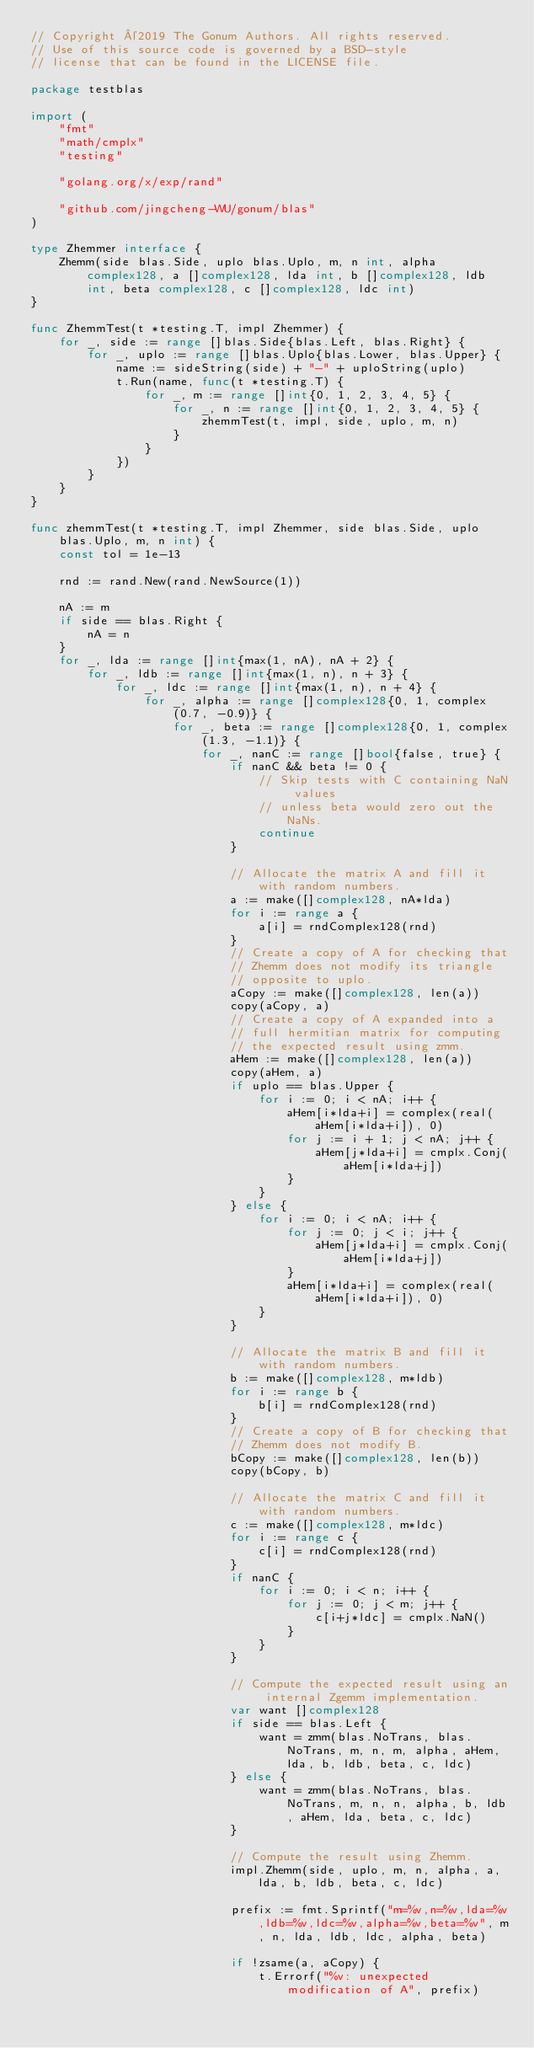<code> <loc_0><loc_0><loc_500><loc_500><_Go_>// Copyright ©2019 The Gonum Authors. All rights reserved.
// Use of this source code is governed by a BSD-style
// license that can be found in the LICENSE file.

package testblas

import (
	"fmt"
	"math/cmplx"
	"testing"

	"golang.org/x/exp/rand"

	"github.com/jingcheng-WU/gonum/blas"
)

type Zhemmer interface {
	Zhemm(side blas.Side, uplo blas.Uplo, m, n int, alpha complex128, a []complex128, lda int, b []complex128, ldb int, beta complex128, c []complex128, ldc int)
}

func ZhemmTest(t *testing.T, impl Zhemmer) {
	for _, side := range []blas.Side{blas.Left, blas.Right} {
		for _, uplo := range []blas.Uplo{blas.Lower, blas.Upper} {
			name := sideString(side) + "-" + uploString(uplo)
			t.Run(name, func(t *testing.T) {
				for _, m := range []int{0, 1, 2, 3, 4, 5} {
					for _, n := range []int{0, 1, 2, 3, 4, 5} {
						zhemmTest(t, impl, side, uplo, m, n)
					}
				}
			})
		}
	}
}

func zhemmTest(t *testing.T, impl Zhemmer, side blas.Side, uplo blas.Uplo, m, n int) {
	const tol = 1e-13

	rnd := rand.New(rand.NewSource(1))

	nA := m
	if side == blas.Right {
		nA = n
	}
	for _, lda := range []int{max(1, nA), nA + 2} {
		for _, ldb := range []int{max(1, n), n + 3} {
			for _, ldc := range []int{max(1, n), n + 4} {
				for _, alpha := range []complex128{0, 1, complex(0.7, -0.9)} {
					for _, beta := range []complex128{0, 1, complex(1.3, -1.1)} {
						for _, nanC := range []bool{false, true} {
							if nanC && beta != 0 {
								// Skip tests with C containing NaN values
								// unless beta would zero out the NaNs.
								continue
							}

							// Allocate the matrix A and fill it with random numbers.
							a := make([]complex128, nA*lda)
							for i := range a {
								a[i] = rndComplex128(rnd)
							}
							// Create a copy of A for checking that
							// Zhemm does not modify its triangle
							// opposite to uplo.
							aCopy := make([]complex128, len(a))
							copy(aCopy, a)
							// Create a copy of A expanded into a
							// full hermitian matrix for computing
							// the expected result using zmm.
							aHem := make([]complex128, len(a))
							copy(aHem, a)
							if uplo == blas.Upper {
								for i := 0; i < nA; i++ {
									aHem[i*lda+i] = complex(real(aHem[i*lda+i]), 0)
									for j := i + 1; j < nA; j++ {
										aHem[j*lda+i] = cmplx.Conj(aHem[i*lda+j])
									}
								}
							} else {
								for i := 0; i < nA; i++ {
									for j := 0; j < i; j++ {
										aHem[j*lda+i] = cmplx.Conj(aHem[i*lda+j])
									}
									aHem[i*lda+i] = complex(real(aHem[i*lda+i]), 0)
								}
							}

							// Allocate the matrix B and fill it with random numbers.
							b := make([]complex128, m*ldb)
							for i := range b {
								b[i] = rndComplex128(rnd)
							}
							// Create a copy of B for checking that
							// Zhemm does not modify B.
							bCopy := make([]complex128, len(b))
							copy(bCopy, b)

							// Allocate the matrix C and fill it with random numbers.
							c := make([]complex128, m*ldc)
							for i := range c {
								c[i] = rndComplex128(rnd)
							}
							if nanC {
								for i := 0; i < n; i++ {
									for j := 0; j < m; j++ {
										c[i+j*ldc] = cmplx.NaN()
									}
								}
							}

							// Compute the expected result using an internal Zgemm implementation.
							var want []complex128
							if side == blas.Left {
								want = zmm(blas.NoTrans, blas.NoTrans, m, n, m, alpha, aHem, lda, b, ldb, beta, c, ldc)
							} else {
								want = zmm(blas.NoTrans, blas.NoTrans, m, n, n, alpha, b, ldb, aHem, lda, beta, c, ldc)
							}

							// Compute the result using Zhemm.
							impl.Zhemm(side, uplo, m, n, alpha, a, lda, b, ldb, beta, c, ldc)

							prefix := fmt.Sprintf("m=%v,n=%v,lda=%v,ldb=%v,ldc=%v,alpha=%v,beta=%v", m, n, lda, ldb, ldc, alpha, beta)

							if !zsame(a, aCopy) {
								t.Errorf("%v: unexpected modification of A", prefix)</code> 